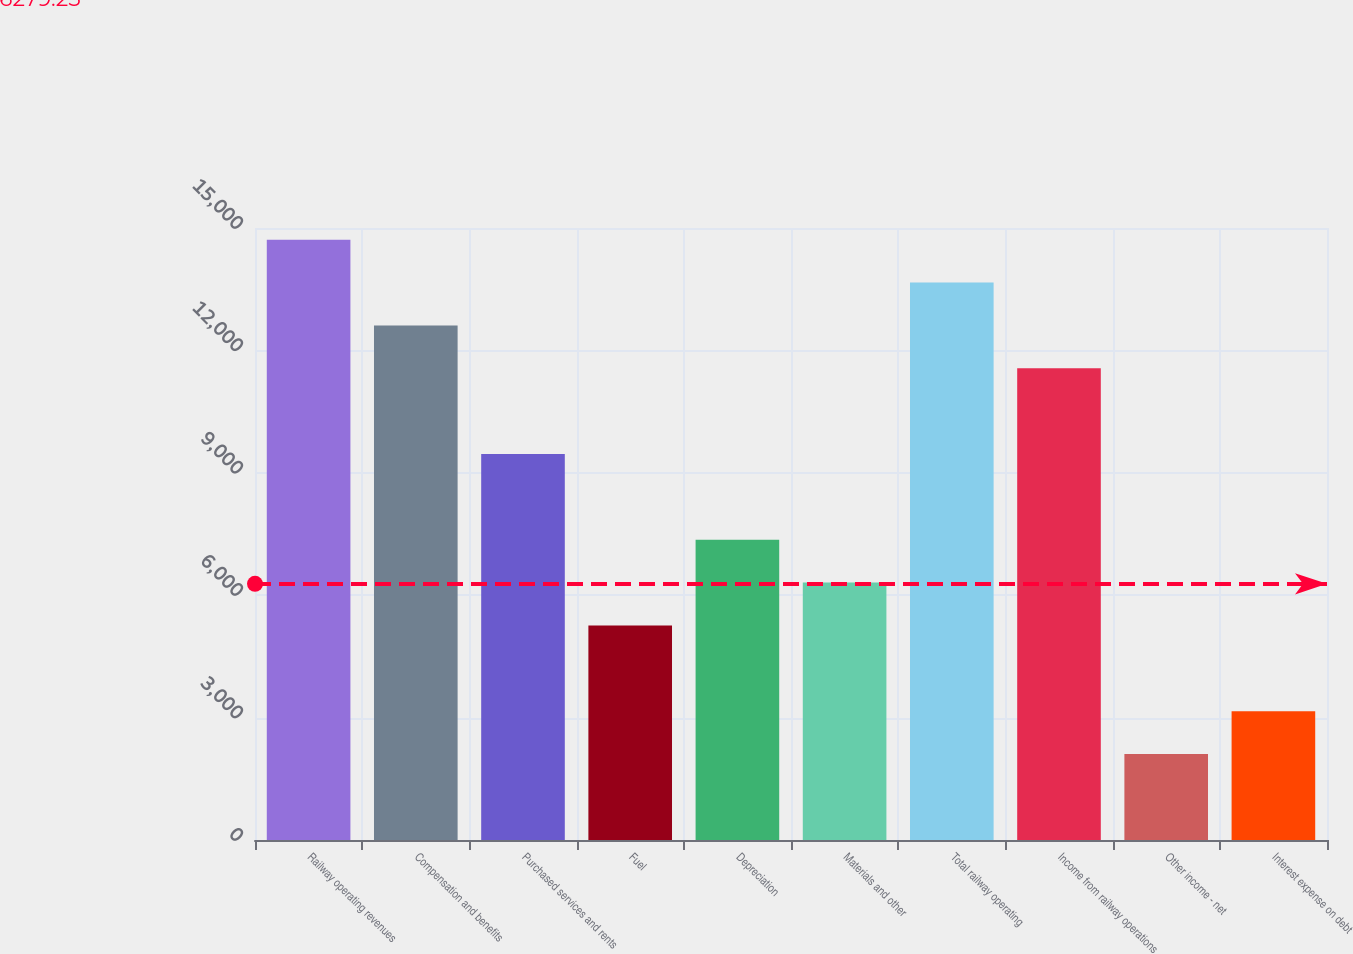<chart> <loc_0><loc_0><loc_500><loc_500><bar_chart><fcel>Railway operating revenues<fcel>Compensation and benefits<fcel>Purchased services and rents<fcel>Fuel<fcel>Depreciation<fcel>Materials and other<fcel>Total railway operating<fcel>Income from railway operations<fcel>Other income - net<fcel>Interest expense on debt<nl><fcel>14713.4<fcel>12612.2<fcel>9460.41<fcel>5258.05<fcel>7359.23<fcel>6308.64<fcel>13662.8<fcel>11561.6<fcel>2106.28<fcel>3156.87<nl></chart> 